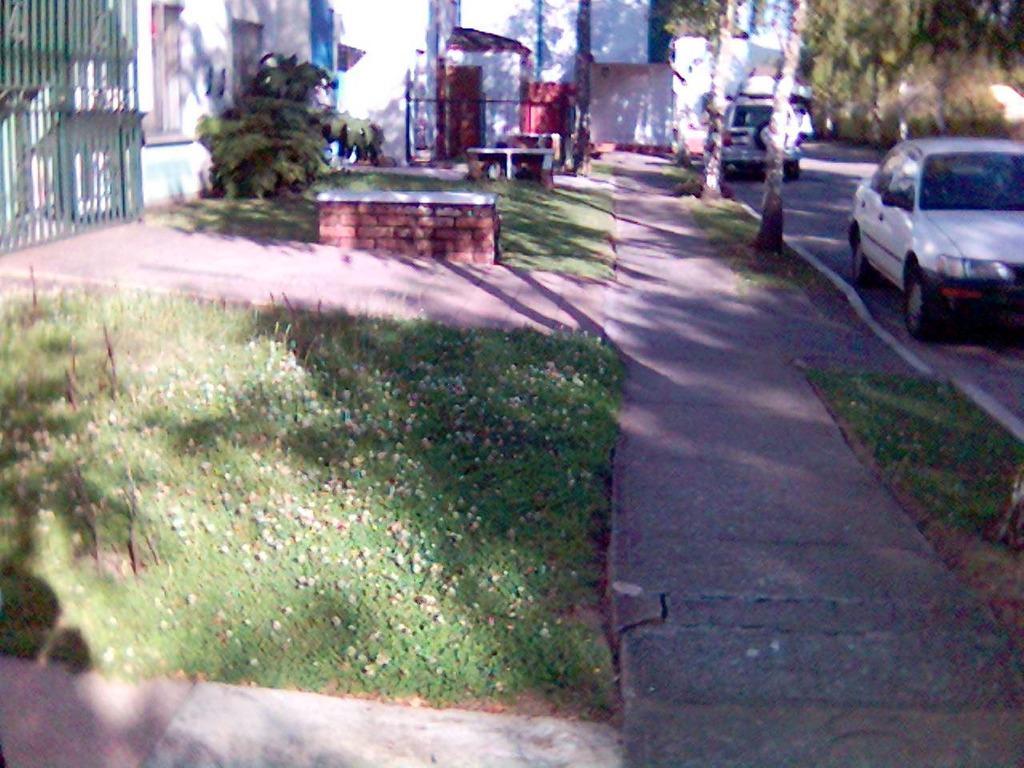How would you summarize this image in a sentence or two? In this image we can see grass, plants, path, wall, gate, and trees. There are vehicles on the road. 